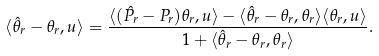<formula> <loc_0><loc_0><loc_500><loc_500>\langle \hat { \theta } _ { r } - \theta _ { r } , u \rangle = \frac { \langle ( \hat { P } _ { r } - P _ { r } ) \theta _ { r } , u \rangle - \langle \hat { \theta } _ { r } - \theta _ { r } , \theta _ { r } \rangle \langle \theta _ { r } , u \rangle } { 1 + \langle \hat { \theta } _ { r } - \theta _ { r } , \theta _ { r } \rangle } .</formula> 